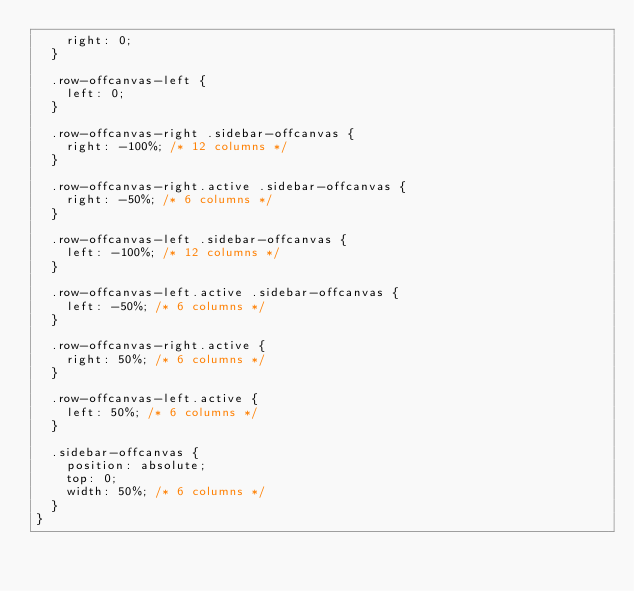<code> <loc_0><loc_0><loc_500><loc_500><_CSS_>    right: 0;
  }

  .row-offcanvas-left {
    left: 0;
  }

  .row-offcanvas-right .sidebar-offcanvas {
    right: -100%; /* 12 columns */
  }

  .row-offcanvas-right.active .sidebar-offcanvas {
    right: -50%; /* 6 columns */
  }

  .row-offcanvas-left .sidebar-offcanvas {
    left: -100%; /* 12 columns */
  }

  .row-offcanvas-left.active .sidebar-offcanvas {
    left: -50%; /* 6 columns */
  }

  .row-offcanvas-right.active {
    right: 50%; /* 6 columns */
  }

  .row-offcanvas-left.active {
    left: 50%; /* 6 columns */
  }

  .sidebar-offcanvas {
    position: absolute;
    top: 0;
    width: 50%; /* 6 columns */
  }
}
</code> 